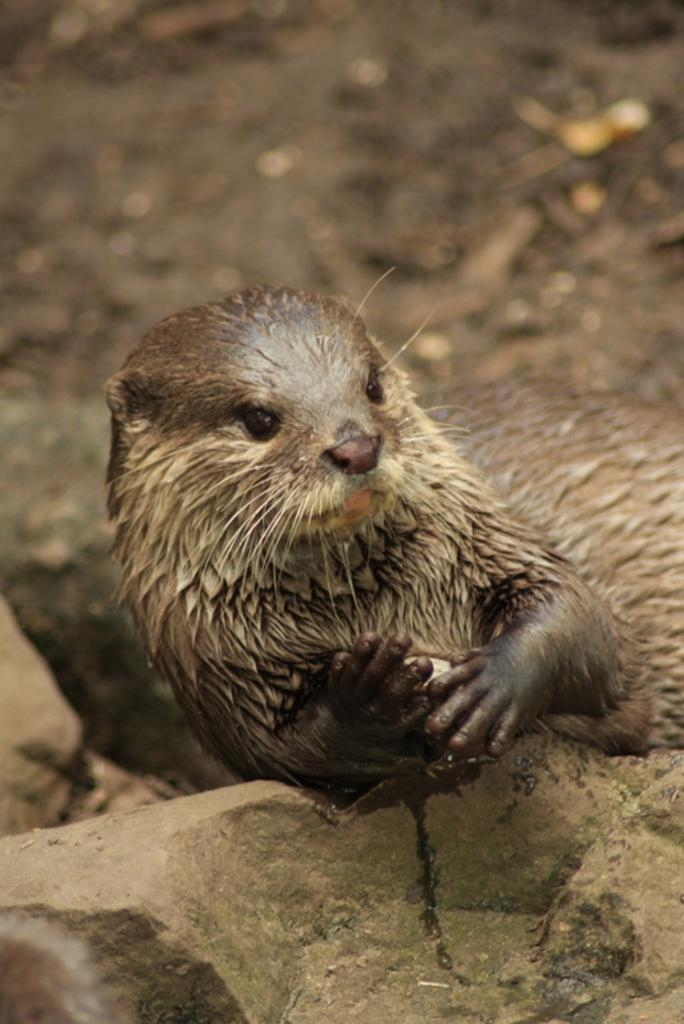What animal is present in the image? There is a sloth in the image. What is the sloth resting on? The sloth is on a rock. What color is the sloth? The sloth is brown in color. What type of surface can be seen in the background of the image? There is ground visible in the background of the image. What type of jam is the sloth spreading on the toast in the image? There is no jam or toast present in the image; it features a sloth on a rock. 